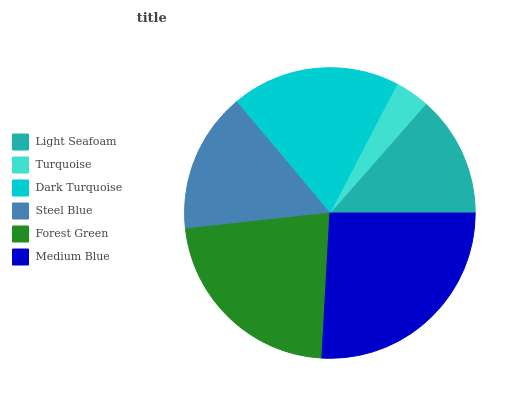Is Turquoise the minimum?
Answer yes or no. Yes. Is Medium Blue the maximum?
Answer yes or no. Yes. Is Dark Turquoise the minimum?
Answer yes or no. No. Is Dark Turquoise the maximum?
Answer yes or no. No. Is Dark Turquoise greater than Turquoise?
Answer yes or no. Yes. Is Turquoise less than Dark Turquoise?
Answer yes or no. Yes. Is Turquoise greater than Dark Turquoise?
Answer yes or no. No. Is Dark Turquoise less than Turquoise?
Answer yes or no. No. Is Dark Turquoise the high median?
Answer yes or no. Yes. Is Steel Blue the low median?
Answer yes or no. Yes. Is Light Seafoam the high median?
Answer yes or no. No. Is Light Seafoam the low median?
Answer yes or no. No. 